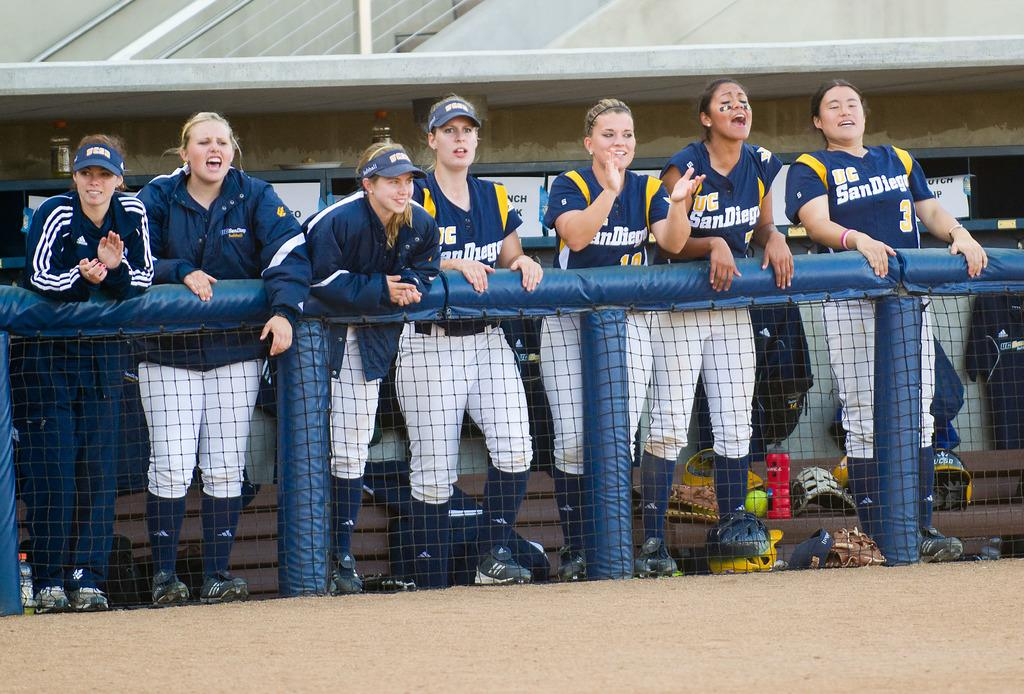<image>
Render a clear and concise summary of the photo. Girls softball players in blue jerseys from San Diego. 